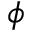<formula> <loc_0><loc_0><loc_500><loc_500>\phi</formula> 